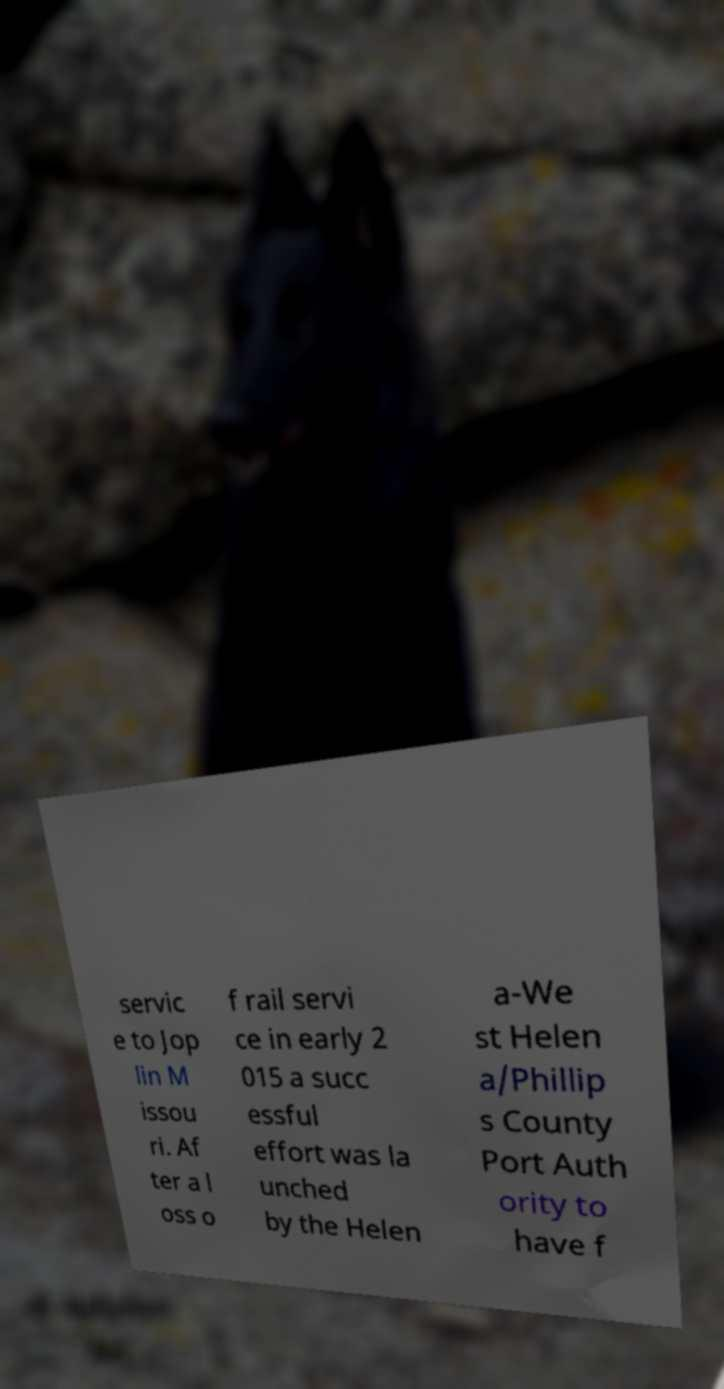Please read and relay the text visible in this image. What does it say? servic e to Jop lin M issou ri. Af ter a l oss o f rail servi ce in early 2 015 a succ essful effort was la unched by the Helen a-We st Helen a/Phillip s County Port Auth ority to have f 